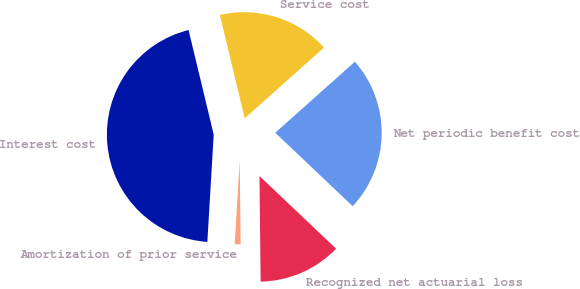<chart> <loc_0><loc_0><loc_500><loc_500><pie_chart><fcel>Service cost<fcel>Interest cost<fcel>Amortization of prior service<fcel>Recognized net actuarial loss<fcel>Net periodic benefit cost<nl><fcel>17.16%<fcel>45.31%<fcel>1.12%<fcel>12.74%<fcel>23.68%<nl></chart> 